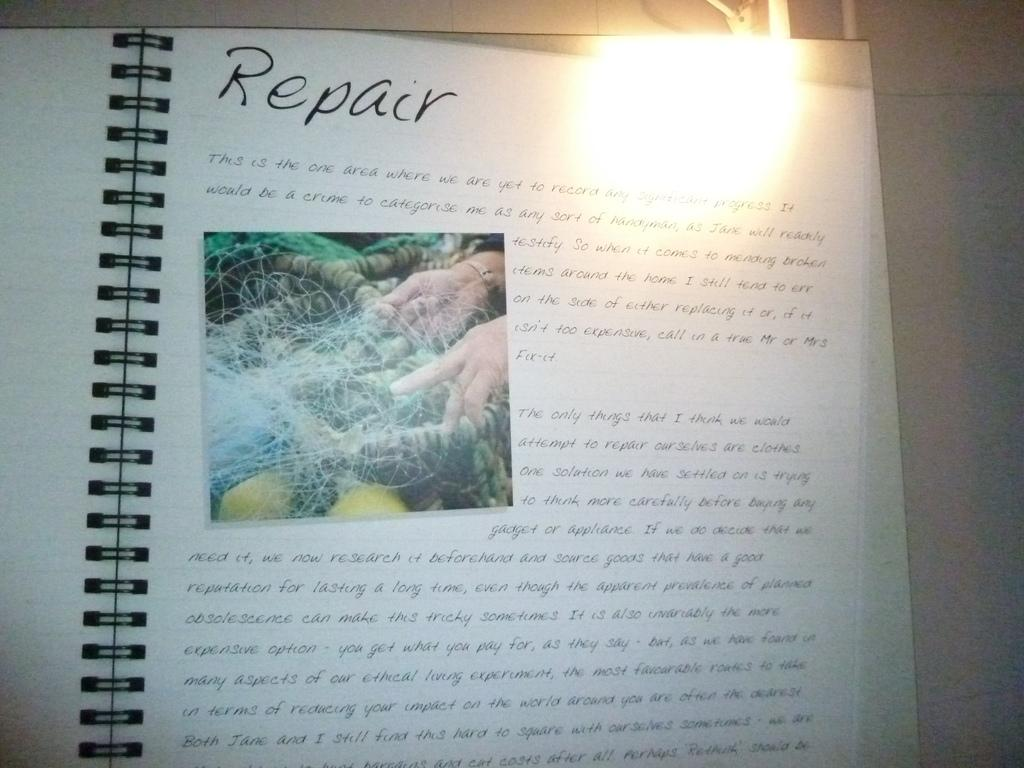<image>
Share a concise interpretation of the image provided. An open ring bound book which has the word Repair on the top. 